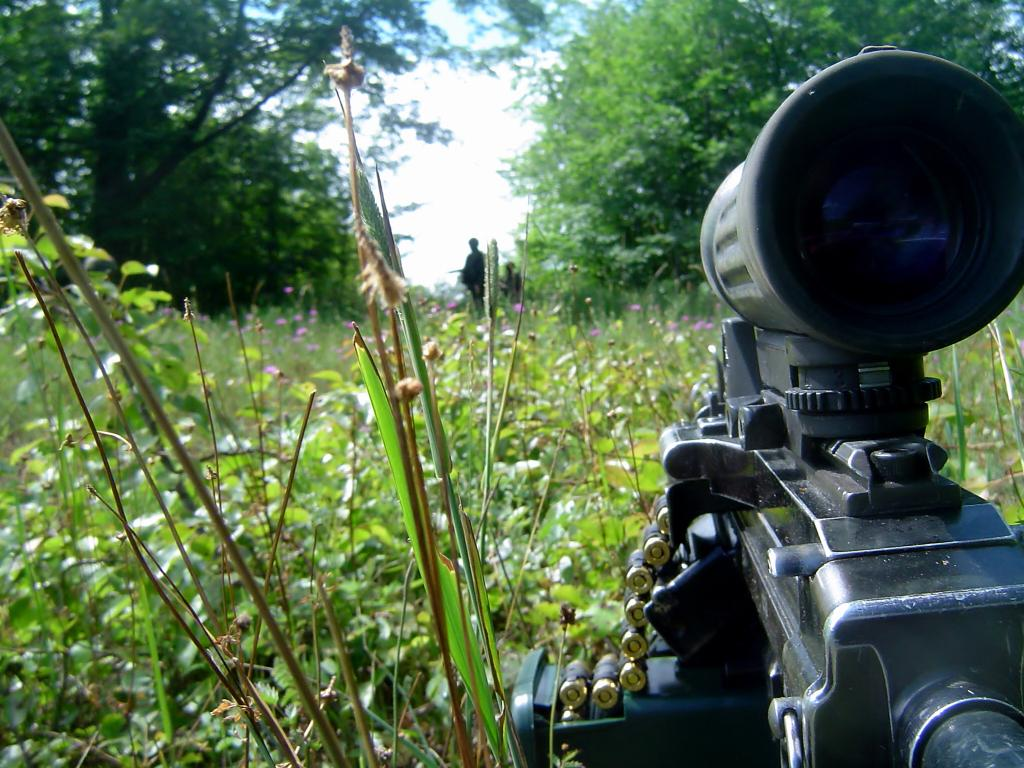What is the main object in the image that contains bullets? There is a machine with bullets in the image. What type of natural elements can be seen in the image? There are trees, plants, and flowers in the image. Are there any living beings present in the image? Yes, there are persons in the image. What type of beds can be seen in the image? There are no beds present in the image. What substance is the flower made of in the image? The image does not provide information about the composition of the flowers; they are likely made of organic materials like petals and stems. 